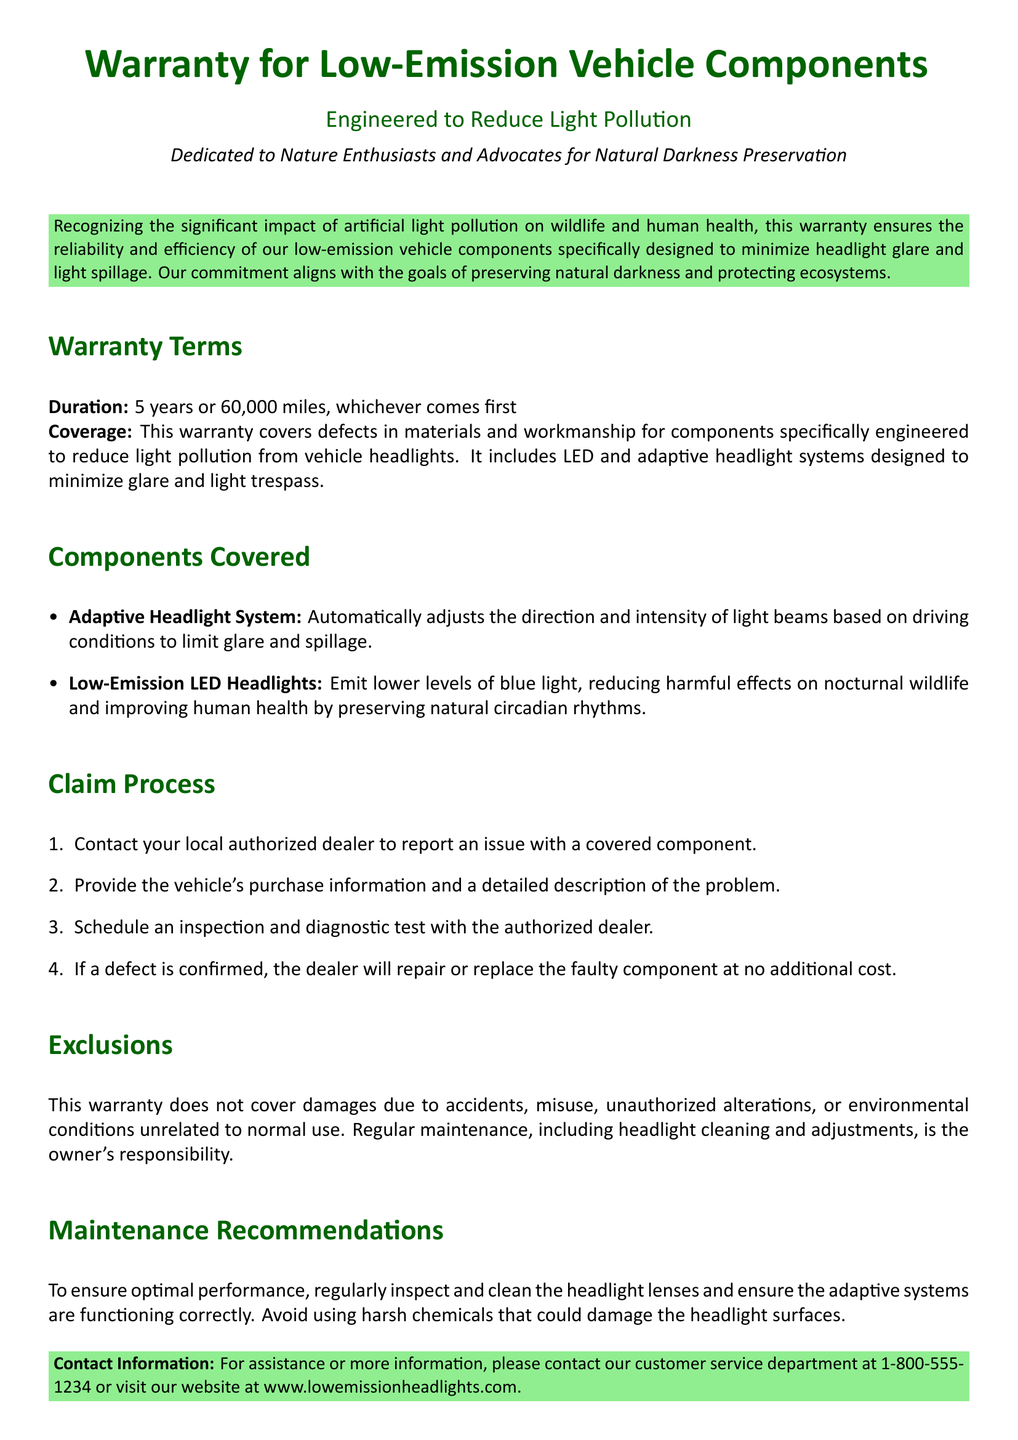What is the duration of the warranty? The warranty lasts for a period of 5 years or 60,000 miles, whichever comes first.
Answer: 5 years or 60,000 miles What components are specifically covered under this warranty? The warranty covers defects in materials and workmanship for components designed to reduce light pollution, including adaptive headlight systems and LED headlights.
Answer: Adaptive Headlight System, Low-Emission LED Headlights Which type of light is reduced by the low-emission LED headlights? Low-emission LED headlights are specifically designed to emit lower levels of blue light.
Answer: Blue light What must a vehicle owner do first when claiming a warranty? The first step in the claim process is to contact the local authorized dealer to report an issue.
Answer: Contact local authorized dealer What is not covered under this warranty? The warranty does not cover damages due to accidents, misuse, or unauthorized alterations.
Answer: Accidents, misuse, unauthorized alterations How can a customer contact customer service? The document provides a phone number and website for customer service contact.
Answer: 1-800-555-1234, www.lowemissionheadlights.com 